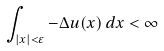<formula> <loc_0><loc_0><loc_500><loc_500>\int _ { | x | < \varepsilon } - \Delta u ( x ) \, d x < \infty</formula> 